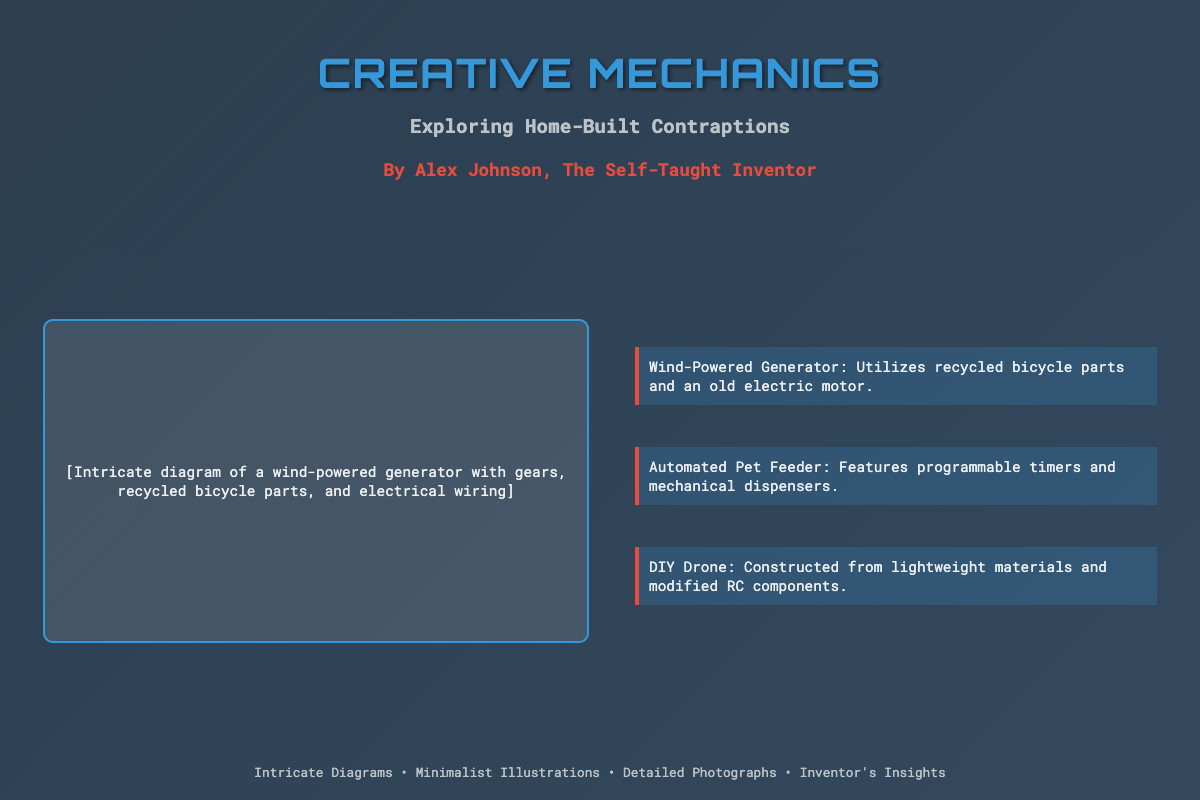What is the title of the book? The title is displayed prominently at the top of the cover in a large font.
Answer: Creative Mechanics Who is the author of the book? The author's name is listed directly below the subtitle in bold font.
Answer: Alex Johnson What type of diagram is featured on the cover? The diagram is described in the content area and shows a specific mechanical invention.
Answer: Wind-powered generator How many gadgets are listed in the content area? The number of gadgets can be counted from the descriptions provided in the content section.
Answer: Three What color is the title text? The color of the title text can be identified from the style of the text on the cover.
Answer: Blue What feature does the Automated Pet Feeder include? This feature is highlighted in the description of the gadget in the content area.
Answer: Programmable timers What is the main theme of the book? The theme can be inferred from the title and subtitle presented on the cover.
Answer: Home-built contraptions What type of illustrations does the book showcase? The book cover mentions the type of visual representation provided within the book.
Answer: Minimalist illustrations What is the background color gradient on the cover? The background color can be found in the styling information of the cover layout.
Answer: Dark blue to grey 